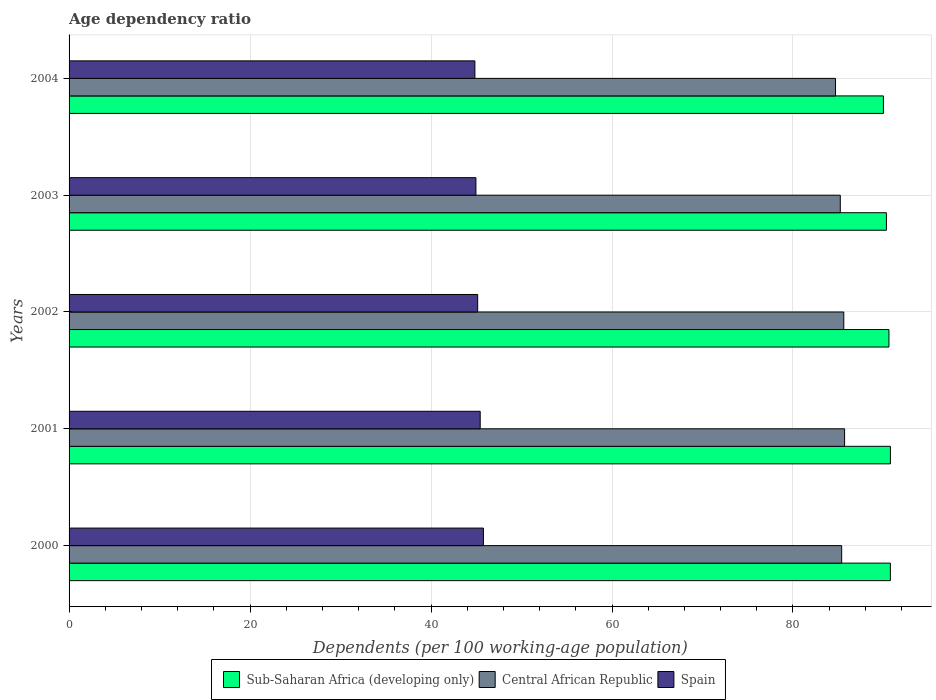How many different coloured bars are there?
Make the answer very short. 3. Are the number of bars per tick equal to the number of legend labels?
Offer a very short reply. Yes. How many bars are there on the 4th tick from the top?
Your answer should be very brief. 3. How many bars are there on the 1st tick from the bottom?
Make the answer very short. 3. What is the label of the 4th group of bars from the top?
Your answer should be compact. 2001. In how many cases, is the number of bars for a given year not equal to the number of legend labels?
Your response must be concise. 0. What is the age dependency ratio in in Central African Republic in 2000?
Give a very brief answer. 85.38. Across all years, what is the maximum age dependency ratio in in Central African Republic?
Offer a terse response. 85.7. Across all years, what is the minimum age dependency ratio in in Sub-Saharan Africa (developing only)?
Your answer should be compact. 89.99. What is the total age dependency ratio in in Sub-Saharan Africa (developing only) in the graph?
Give a very brief answer. 452.45. What is the difference between the age dependency ratio in in Spain in 2000 and that in 2002?
Make the answer very short. 0.64. What is the difference between the age dependency ratio in in Sub-Saharan Africa (developing only) in 2004 and the age dependency ratio in in Central African Republic in 2003?
Your response must be concise. 4.77. What is the average age dependency ratio in in Central African Republic per year?
Provide a short and direct response. 85.32. In the year 2004, what is the difference between the age dependency ratio in in Sub-Saharan Africa (developing only) and age dependency ratio in in Central African Republic?
Offer a very short reply. 5.29. What is the ratio of the age dependency ratio in in Sub-Saharan Africa (developing only) in 2000 to that in 2003?
Your answer should be compact. 1. Is the age dependency ratio in in Spain in 2001 less than that in 2003?
Provide a succinct answer. No. Is the difference between the age dependency ratio in in Sub-Saharan Africa (developing only) in 2001 and 2003 greater than the difference between the age dependency ratio in in Central African Republic in 2001 and 2003?
Provide a short and direct response. No. What is the difference between the highest and the second highest age dependency ratio in in Central African Republic?
Offer a very short reply. 0.09. What is the difference between the highest and the lowest age dependency ratio in in Central African Republic?
Ensure brevity in your answer.  1. In how many years, is the age dependency ratio in in Spain greater than the average age dependency ratio in in Spain taken over all years?
Give a very brief answer. 2. Is the sum of the age dependency ratio in in Sub-Saharan Africa (developing only) in 2002 and 2003 greater than the maximum age dependency ratio in in Spain across all years?
Give a very brief answer. Yes. What does the 2nd bar from the top in 2001 represents?
Make the answer very short. Central African Republic. What does the 2nd bar from the bottom in 2002 represents?
Give a very brief answer. Central African Republic. Are all the bars in the graph horizontal?
Make the answer very short. Yes. How many years are there in the graph?
Your answer should be very brief. 5. What is the difference between two consecutive major ticks on the X-axis?
Provide a succinct answer. 20. Are the values on the major ticks of X-axis written in scientific E-notation?
Ensure brevity in your answer.  No. Does the graph contain any zero values?
Offer a terse response. No. Does the graph contain grids?
Your answer should be very brief. Yes. Where does the legend appear in the graph?
Your answer should be very brief. Bottom center. How are the legend labels stacked?
Keep it short and to the point. Horizontal. What is the title of the graph?
Offer a very short reply. Age dependency ratio. What is the label or title of the X-axis?
Provide a short and direct response. Dependents (per 100 working-age population). What is the label or title of the Y-axis?
Ensure brevity in your answer.  Years. What is the Dependents (per 100 working-age population) of Sub-Saharan Africa (developing only) in 2000?
Offer a very short reply. 90.76. What is the Dependents (per 100 working-age population) in Central African Republic in 2000?
Give a very brief answer. 85.38. What is the Dependents (per 100 working-age population) of Spain in 2000?
Provide a succinct answer. 45.79. What is the Dependents (per 100 working-age population) of Sub-Saharan Africa (developing only) in 2001?
Offer a terse response. 90.77. What is the Dependents (per 100 working-age population) of Central African Republic in 2001?
Provide a succinct answer. 85.7. What is the Dependents (per 100 working-age population) in Spain in 2001?
Your response must be concise. 45.43. What is the Dependents (per 100 working-age population) in Sub-Saharan Africa (developing only) in 2002?
Offer a very short reply. 90.6. What is the Dependents (per 100 working-age population) in Central African Republic in 2002?
Keep it short and to the point. 85.61. What is the Dependents (per 100 working-age population) of Spain in 2002?
Provide a short and direct response. 45.15. What is the Dependents (per 100 working-age population) of Sub-Saharan Africa (developing only) in 2003?
Give a very brief answer. 90.33. What is the Dependents (per 100 working-age population) of Central African Republic in 2003?
Make the answer very short. 85.23. What is the Dependents (per 100 working-age population) of Spain in 2003?
Give a very brief answer. 44.96. What is the Dependents (per 100 working-age population) in Sub-Saharan Africa (developing only) in 2004?
Offer a very short reply. 89.99. What is the Dependents (per 100 working-age population) in Central African Republic in 2004?
Give a very brief answer. 84.7. What is the Dependents (per 100 working-age population) in Spain in 2004?
Your answer should be very brief. 44.85. Across all years, what is the maximum Dependents (per 100 working-age population) in Sub-Saharan Africa (developing only)?
Offer a terse response. 90.77. Across all years, what is the maximum Dependents (per 100 working-age population) of Central African Republic?
Provide a short and direct response. 85.7. Across all years, what is the maximum Dependents (per 100 working-age population) in Spain?
Give a very brief answer. 45.79. Across all years, what is the minimum Dependents (per 100 working-age population) in Sub-Saharan Africa (developing only)?
Make the answer very short. 89.99. Across all years, what is the minimum Dependents (per 100 working-age population) in Central African Republic?
Offer a very short reply. 84.7. Across all years, what is the minimum Dependents (per 100 working-age population) in Spain?
Make the answer very short. 44.85. What is the total Dependents (per 100 working-age population) in Sub-Saharan Africa (developing only) in the graph?
Offer a terse response. 452.45. What is the total Dependents (per 100 working-age population) of Central African Republic in the graph?
Your response must be concise. 426.62. What is the total Dependents (per 100 working-age population) of Spain in the graph?
Make the answer very short. 226.19. What is the difference between the Dependents (per 100 working-age population) in Sub-Saharan Africa (developing only) in 2000 and that in 2001?
Offer a terse response. -0.01. What is the difference between the Dependents (per 100 working-age population) of Central African Republic in 2000 and that in 2001?
Keep it short and to the point. -0.32. What is the difference between the Dependents (per 100 working-age population) in Spain in 2000 and that in 2001?
Provide a short and direct response. 0.36. What is the difference between the Dependents (per 100 working-age population) of Sub-Saharan Africa (developing only) in 2000 and that in 2002?
Your response must be concise. 0.16. What is the difference between the Dependents (per 100 working-age population) of Central African Republic in 2000 and that in 2002?
Offer a terse response. -0.23. What is the difference between the Dependents (per 100 working-age population) of Spain in 2000 and that in 2002?
Your answer should be very brief. 0.64. What is the difference between the Dependents (per 100 working-age population) of Sub-Saharan Africa (developing only) in 2000 and that in 2003?
Ensure brevity in your answer.  0.44. What is the difference between the Dependents (per 100 working-age population) in Central African Republic in 2000 and that in 2003?
Make the answer very short. 0.15. What is the difference between the Dependents (per 100 working-age population) in Spain in 2000 and that in 2003?
Keep it short and to the point. 0.83. What is the difference between the Dependents (per 100 working-age population) in Sub-Saharan Africa (developing only) in 2000 and that in 2004?
Keep it short and to the point. 0.77. What is the difference between the Dependents (per 100 working-age population) of Central African Republic in 2000 and that in 2004?
Keep it short and to the point. 0.68. What is the difference between the Dependents (per 100 working-age population) of Spain in 2000 and that in 2004?
Provide a succinct answer. 0.94. What is the difference between the Dependents (per 100 working-age population) of Sub-Saharan Africa (developing only) in 2001 and that in 2002?
Keep it short and to the point. 0.16. What is the difference between the Dependents (per 100 working-age population) in Central African Republic in 2001 and that in 2002?
Your response must be concise. 0.09. What is the difference between the Dependents (per 100 working-age population) in Spain in 2001 and that in 2002?
Offer a very short reply. 0.28. What is the difference between the Dependents (per 100 working-age population) of Sub-Saharan Africa (developing only) in 2001 and that in 2003?
Your answer should be very brief. 0.44. What is the difference between the Dependents (per 100 working-age population) of Central African Republic in 2001 and that in 2003?
Give a very brief answer. 0.47. What is the difference between the Dependents (per 100 working-age population) in Spain in 2001 and that in 2003?
Provide a succinct answer. 0.47. What is the difference between the Dependents (per 100 working-age population) in Sub-Saharan Africa (developing only) in 2001 and that in 2004?
Your response must be concise. 0.77. What is the difference between the Dependents (per 100 working-age population) in Central African Republic in 2001 and that in 2004?
Keep it short and to the point. 1. What is the difference between the Dependents (per 100 working-age population) in Spain in 2001 and that in 2004?
Your response must be concise. 0.59. What is the difference between the Dependents (per 100 working-age population) of Sub-Saharan Africa (developing only) in 2002 and that in 2003?
Offer a terse response. 0.28. What is the difference between the Dependents (per 100 working-age population) of Central African Republic in 2002 and that in 2003?
Offer a terse response. 0.39. What is the difference between the Dependents (per 100 working-age population) of Spain in 2002 and that in 2003?
Provide a short and direct response. 0.19. What is the difference between the Dependents (per 100 working-age population) of Sub-Saharan Africa (developing only) in 2002 and that in 2004?
Provide a succinct answer. 0.61. What is the difference between the Dependents (per 100 working-age population) of Central African Republic in 2002 and that in 2004?
Offer a terse response. 0.91. What is the difference between the Dependents (per 100 working-age population) of Spain in 2002 and that in 2004?
Offer a terse response. 0.31. What is the difference between the Dependents (per 100 working-age population) of Sub-Saharan Africa (developing only) in 2003 and that in 2004?
Keep it short and to the point. 0.33. What is the difference between the Dependents (per 100 working-age population) of Central African Republic in 2003 and that in 2004?
Your answer should be very brief. 0.53. What is the difference between the Dependents (per 100 working-age population) in Spain in 2003 and that in 2004?
Make the answer very short. 0.11. What is the difference between the Dependents (per 100 working-age population) of Sub-Saharan Africa (developing only) in 2000 and the Dependents (per 100 working-age population) of Central African Republic in 2001?
Your response must be concise. 5.06. What is the difference between the Dependents (per 100 working-age population) in Sub-Saharan Africa (developing only) in 2000 and the Dependents (per 100 working-age population) in Spain in 2001?
Offer a terse response. 45.33. What is the difference between the Dependents (per 100 working-age population) in Central African Republic in 2000 and the Dependents (per 100 working-age population) in Spain in 2001?
Make the answer very short. 39.94. What is the difference between the Dependents (per 100 working-age population) of Sub-Saharan Africa (developing only) in 2000 and the Dependents (per 100 working-age population) of Central African Republic in 2002?
Your response must be concise. 5.15. What is the difference between the Dependents (per 100 working-age population) in Sub-Saharan Africa (developing only) in 2000 and the Dependents (per 100 working-age population) in Spain in 2002?
Your response must be concise. 45.61. What is the difference between the Dependents (per 100 working-age population) in Central African Republic in 2000 and the Dependents (per 100 working-age population) in Spain in 2002?
Provide a short and direct response. 40.22. What is the difference between the Dependents (per 100 working-age population) of Sub-Saharan Africa (developing only) in 2000 and the Dependents (per 100 working-age population) of Central African Republic in 2003?
Give a very brief answer. 5.54. What is the difference between the Dependents (per 100 working-age population) in Sub-Saharan Africa (developing only) in 2000 and the Dependents (per 100 working-age population) in Spain in 2003?
Offer a very short reply. 45.8. What is the difference between the Dependents (per 100 working-age population) in Central African Republic in 2000 and the Dependents (per 100 working-age population) in Spain in 2003?
Offer a terse response. 40.42. What is the difference between the Dependents (per 100 working-age population) in Sub-Saharan Africa (developing only) in 2000 and the Dependents (per 100 working-age population) in Central African Republic in 2004?
Offer a terse response. 6.06. What is the difference between the Dependents (per 100 working-age population) in Sub-Saharan Africa (developing only) in 2000 and the Dependents (per 100 working-age population) in Spain in 2004?
Your response must be concise. 45.92. What is the difference between the Dependents (per 100 working-age population) in Central African Republic in 2000 and the Dependents (per 100 working-age population) in Spain in 2004?
Make the answer very short. 40.53. What is the difference between the Dependents (per 100 working-age population) in Sub-Saharan Africa (developing only) in 2001 and the Dependents (per 100 working-age population) in Central African Republic in 2002?
Provide a short and direct response. 5.16. What is the difference between the Dependents (per 100 working-age population) in Sub-Saharan Africa (developing only) in 2001 and the Dependents (per 100 working-age population) in Spain in 2002?
Keep it short and to the point. 45.61. What is the difference between the Dependents (per 100 working-age population) in Central African Republic in 2001 and the Dependents (per 100 working-age population) in Spain in 2002?
Your answer should be very brief. 40.55. What is the difference between the Dependents (per 100 working-age population) in Sub-Saharan Africa (developing only) in 2001 and the Dependents (per 100 working-age population) in Central African Republic in 2003?
Ensure brevity in your answer.  5.54. What is the difference between the Dependents (per 100 working-age population) of Sub-Saharan Africa (developing only) in 2001 and the Dependents (per 100 working-age population) of Spain in 2003?
Ensure brevity in your answer.  45.81. What is the difference between the Dependents (per 100 working-age population) of Central African Republic in 2001 and the Dependents (per 100 working-age population) of Spain in 2003?
Keep it short and to the point. 40.74. What is the difference between the Dependents (per 100 working-age population) of Sub-Saharan Africa (developing only) in 2001 and the Dependents (per 100 working-age population) of Central African Republic in 2004?
Make the answer very short. 6.07. What is the difference between the Dependents (per 100 working-age population) in Sub-Saharan Africa (developing only) in 2001 and the Dependents (per 100 working-age population) in Spain in 2004?
Provide a succinct answer. 45.92. What is the difference between the Dependents (per 100 working-age population) of Central African Republic in 2001 and the Dependents (per 100 working-age population) of Spain in 2004?
Your response must be concise. 40.85. What is the difference between the Dependents (per 100 working-age population) in Sub-Saharan Africa (developing only) in 2002 and the Dependents (per 100 working-age population) in Central African Republic in 2003?
Offer a very short reply. 5.38. What is the difference between the Dependents (per 100 working-age population) in Sub-Saharan Africa (developing only) in 2002 and the Dependents (per 100 working-age population) in Spain in 2003?
Your response must be concise. 45.64. What is the difference between the Dependents (per 100 working-age population) of Central African Republic in 2002 and the Dependents (per 100 working-age population) of Spain in 2003?
Your response must be concise. 40.65. What is the difference between the Dependents (per 100 working-age population) of Sub-Saharan Africa (developing only) in 2002 and the Dependents (per 100 working-age population) of Central African Republic in 2004?
Make the answer very short. 5.9. What is the difference between the Dependents (per 100 working-age population) of Sub-Saharan Africa (developing only) in 2002 and the Dependents (per 100 working-age population) of Spain in 2004?
Keep it short and to the point. 45.76. What is the difference between the Dependents (per 100 working-age population) of Central African Republic in 2002 and the Dependents (per 100 working-age population) of Spain in 2004?
Provide a short and direct response. 40.77. What is the difference between the Dependents (per 100 working-age population) in Sub-Saharan Africa (developing only) in 2003 and the Dependents (per 100 working-age population) in Central African Republic in 2004?
Provide a succinct answer. 5.63. What is the difference between the Dependents (per 100 working-age population) in Sub-Saharan Africa (developing only) in 2003 and the Dependents (per 100 working-age population) in Spain in 2004?
Provide a succinct answer. 45.48. What is the difference between the Dependents (per 100 working-age population) of Central African Republic in 2003 and the Dependents (per 100 working-age population) of Spain in 2004?
Offer a very short reply. 40.38. What is the average Dependents (per 100 working-age population) in Sub-Saharan Africa (developing only) per year?
Provide a short and direct response. 90.49. What is the average Dependents (per 100 working-age population) of Central African Republic per year?
Make the answer very short. 85.32. What is the average Dependents (per 100 working-age population) of Spain per year?
Provide a succinct answer. 45.24. In the year 2000, what is the difference between the Dependents (per 100 working-age population) of Sub-Saharan Africa (developing only) and Dependents (per 100 working-age population) of Central African Republic?
Offer a terse response. 5.38. In the year 2000, what is the difference between the Dependents (per 100 working-age population) in Sub-Saharan Africa (developing only) and Dependents (per 100 working-age population) in Spain?
Offer a terse response. 44.97. In the year 2000, what is the difference between the Dependents (per 100 working-age population) of Central African Republic and Dependents (per 100 working-age population) of Spain?
Keep it short and to the point. 39.59. In the year 2001, what is the difference between the Dependents (per 100 working-age population) of Sub-Saharan Africa (developing only) and Dependents (per 100 working-age population) of Central African Republic?
Ensure brevity in your answer.  5.07. In the year 2001, what is the difference between the Dependents (per 100 working-age population) of Sub-Saharan Africa (developing only) and Dependents (per 100 working-age population) of Spain?
Your answer should be very brief. 45.33. In the year 2001, what is the difference between the Dependents (per 100 working-age population) in Central African Republic and Dependents (per 100 working-age population) in Spain?
Give a very brief answer. 40.27. In the year 2002, what is the difference between the Dependents (per 100 working-age population) of Sub-Saharan Africa (developing only) and Dependents (per 100 working-age population) of Central African Republic?
Give a very brief answer. 4.99. In the year 2002, what is the difference between the Dependents (per 100 working-age population) in Sub-Saharan Africa (developing only) and Dependents (per 100 working-age population) in Spain?
Offer a very short reply. 45.45. In the year 2002, what is the difference between the Dependents (per 100 working-age population) in Central African Republic and Dependents (per 100 working-age population) in Spain?
Ensure brevity in your answer.  40.46. In the year 2003, what is the difference between the Dependents (per 100 working-age population) of Sub-Saharan Africa (developing only) and Dependents (per 100 working-age population) of Central African Republic?
Your answer should be compact. 5.1. In the year 2003, what is the difference between the Dependents (per 100 working-age population) of Sub-Saharan Africa (developing only) and Dependents (per 100 working-age population) of Spain?
Your response must be concise. 45.37. In the year 2003, what is the difference between the Dependents (per 100 working-age population) in Central African Republic and Dependents (per 100 working-age population) in Spain?
Provide a short and direct response. 40.27. In the year 2004, what is the difference between the Dependents (per 100 working-age population) of Sub-Saharan Africa (developing only) and Dependents (per 100 working-age population) of Central African Republic?
Keep it short and to the point. 5.29. In the year 2004, what is the difference between the Dependents (per 100 working-age population) in Sub-Saharan Africa (developing only) and Dependents (per 100 working-age population) in Spain?
Give a very brief answer. 45.15. In the year 2004, what is the difference between the Dependents (per 100 working-age population) of Central African Republic and Dependents (per 100 working-age population) of Spain?
Offer a terse response. 39.85. What is the ratio of the Dependents (per 100 working-age population) in Sub-Saharan Africa (developing only) in 2000 to that in 2001?
Keep it short and to the point. 1. What is the ratio of the Dependents (per 100 working-age population) of Central African Republic in 2000 to that in 2002?
Provide a short and direct response. 1. What is the ratio of the Dependents (per 100 working-age population) in Spain in 2000 to that in 2002?
Give a very brief answer. 1.01. What is the ratio of the Dependents (per 100 working-age population) of Spain in 2000 to that in 2003?
Make the answer very short. 1.02. What is the ratio of the Dependents (per 100 working-age population) of Sub-Saharan Africa (developing only) in 2000 to that in 2004?
Make the answer very short. 1.01. What is the ratio of the Dependents (per 100 working-age population) of Central African Republic in 2000 to that in 2004?
Keep it short and to the point. 1.01. What is the ratio of the Dependents (per 100 working-age population) of Sub-Saharan Africa (developing only) in 2001 to that in 2002?
Keep it short and to the point. 1. What is the ratio of the Dependents (per 100 working-age population) of Central African Republic in 2001 to that in 2002?
Ensure brevity in your answer.  1. What is the ratio of the Dependents (per 100 working-age population) of Sub-Saharan Africa (developing only) in 2001 to that in 2003?
Your answer should be very brief. 1. What is the ratio of the Dependents (per 100 working-age population) of Central African Republic in 2001 to that in 2003?
Your response must be concise. 1.01. What is the ratio of the Dependents (per 100 working-age population) of Spain in 2001 to that in 2003?
Your answer should be compact. 1.01. What is the ratio of the Dependents (per 100 working-age population) in Sub-Saharan Africa (developing only) in 2001 to that in 2004?
Give a very brief answer. 1.01. What is the ratio of the Dependents (per 100 working-age population) of Central African Republic in 2001 to that in 2004?
Provide a short and direct response. 1.01. What is the ratio of the Dependents (per 100 working-age population) of Spain in 2001 to that in 2004?
Your answer should be compact. 1.01. What is the ratio of the Dependents (per 100 working-age population) in Sub-Saharan Africa (developing only) in 2002 to that in 2003?
Your answer should be very brief. 1. What is the ratio of the Dependents (per 100 working-age population) of Sub-Saharan Africa (developing only) in 2002 to that in 2004?
Keep it short and to the point. 1.01. What is the ratio of the Dependents (per 100 working-age population) of Central African Republic in 2002 to that in 2004?
Offer a very short reply. 1.01. What is the ratio of the Dependents (per 100 working-age population) in Central African Republic in 2003 to that in 2004?
Your response must be concise. 1.01. What is the difference between the highest and the second highest Dependents (per 100 working-age population) of Sub-Saharan Africa (developing only)?
Provide a short and direct response. 0.01. What is the difference between the highest and the second highest Dependents (per 100 working-age population) in Central African Republic?
Offer a terse response. 0.09. What is the difference between the highest and the second highest Dependents (per 100 working-age population) of Spain?
Provide a short and direct response. 0.36. What is the difference between the highest and the lowest Dependents (per 100 working-age population) of Sub-Saharan Africa (developing only)?
Make the answer very short. 0.77. What is the difference between the highest and the lowest Dependents (per 100 working-age population) in Central African Republic?
Make the answer very short. 1. What is the difference between the highest and the lowest Dependents (per 100 working-age population) of Spain?
Give a very brief answer. 0.94. 